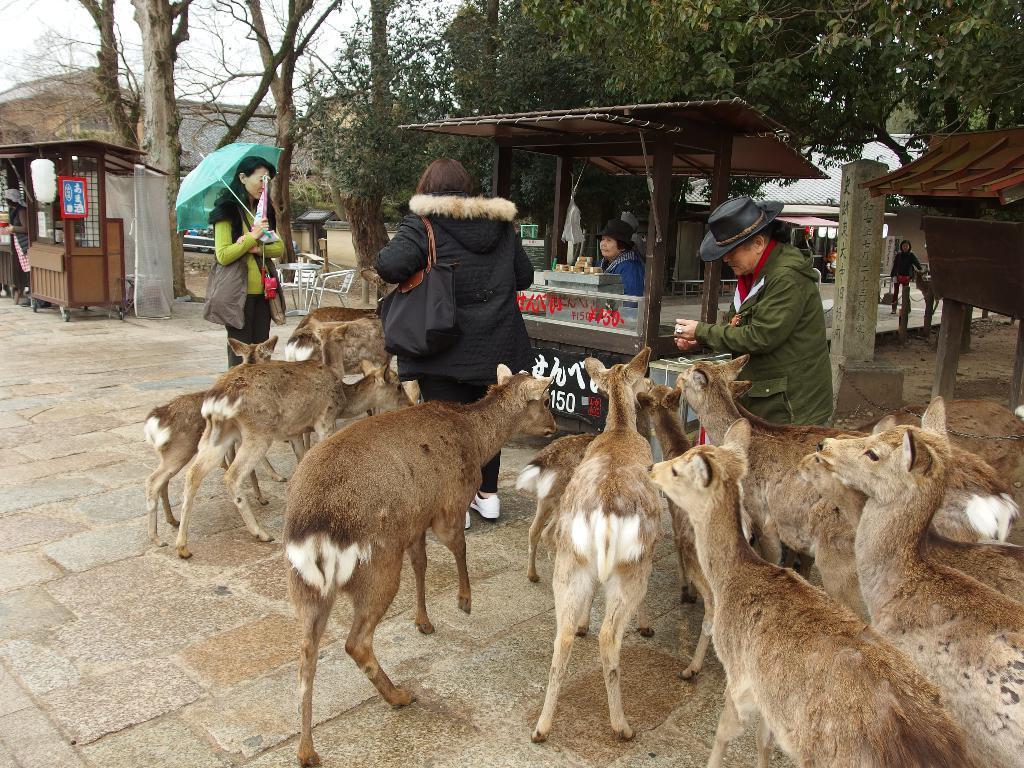How would you summarize this image in a sentence or two? In the center of the image we can see some persons are there. Some of them are wearing coats, hats. Some of them are carrying bag and holding an umbrella. In the background of the image we can see houses, shed, boards, trees, poles. At the top of the image there is a sky. At the bottom of the image we can see ground, animals. 